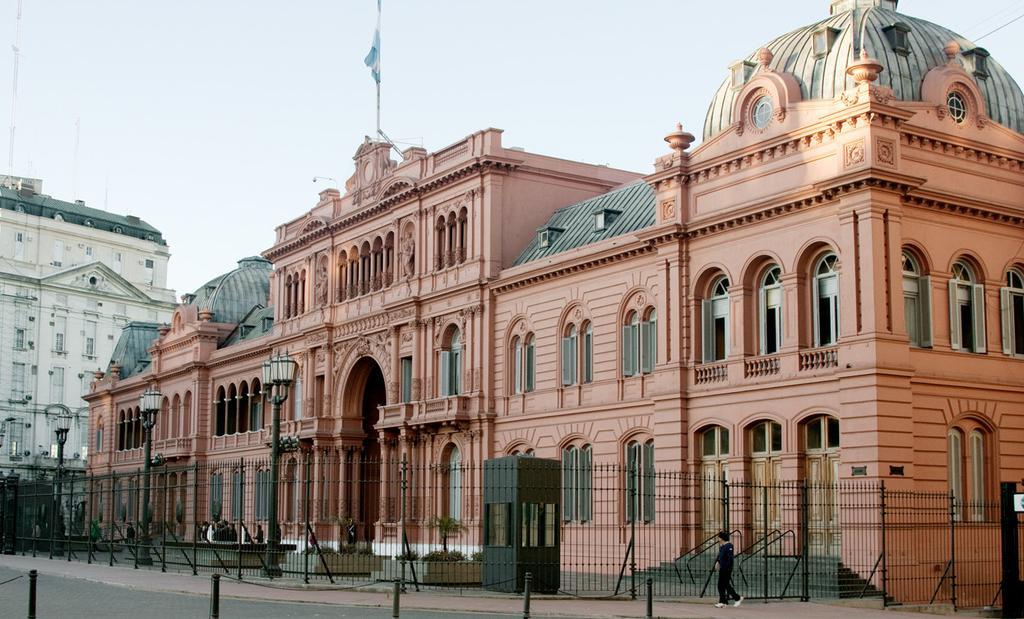Please provide a concise description of this image. In this picture I can see two buildings. There are iron grilles , a pole with flag on top of one of the building, plants , people in front of building, and in the background there is sky. 